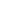<formula> <loc_0><loc_0><loc_500><loc_500>\begin{matrix} & & & * \\ & & & \\ & & & \end{matrix}</formula> 